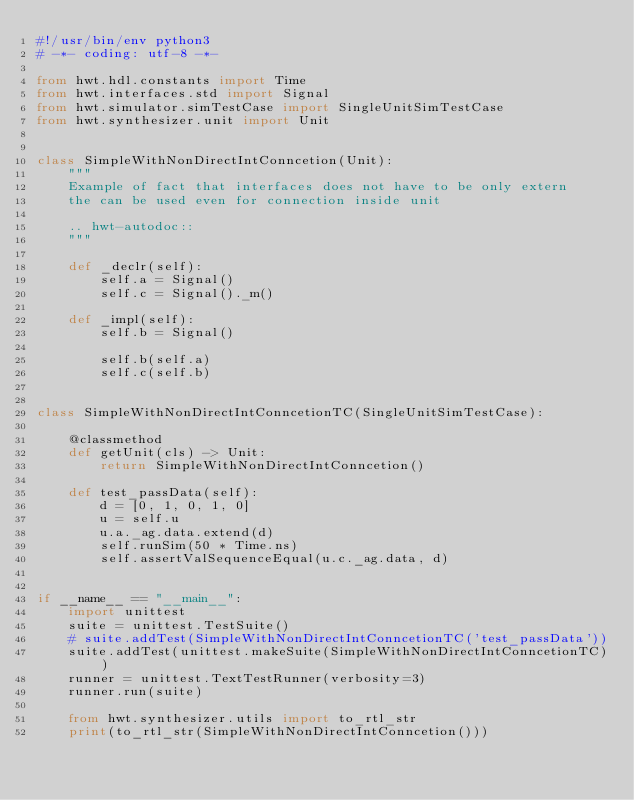Convert code to text. <code><loc_0><loc_0><loc_500><loc_500><_Python_>#!/usr/bin/env python3
# -*- coding: utf-8 -*-

from hwt.hdl.constants import Time
from hwt.interfaces.std import Signal
from hwt.simulator.simTestCase import SingleUnitSimTestCase
from hwt.synthesizer.unit import Unit


class SimpleWithNonDirectIntConncetion(Unit):
    """
    Example of fact that interfaces does not have to be only extern
    the can be used even for connection inside unit

    .. hwt-autodoc::
    """

    def _declr(self):
        self.a = Signal()
        self.c = Signal()._m()

    def _impl(self):
        self.b = Signal()

        self.b(self.a)
        self.c(self.b)


class SimpleWithNonDirectIntConncetionTC(SingleUnitSimTestCase):

    @classmethod
    def getUnit(cls) -> Unit:
        return SimpleWithNonDirectIntConncetion()

    def test_passData(self):
        d = [0, 1, 0, 1, 0]
        u = self.u
        u.a._ag.data.extend(d)
        self.runSim(50 * Time.ns)
        self.assertValSequenceEqual(u.c._ag.data, d)


if __name__ == "__main__":
    import unittest
    suite = unittest.TestSuite()
    # suite.addTest(SimpleWithNonDirectIntConncetionTC('test_passData'))
    suite.addTest(unittest.makeSuite(SimpleWithNonDirectIntConncetionTC))
    runner = unittest.TextTestRunner(verbosity=3)
    runner.run(suite)

    from hwt.synthesizer.utils import to_rtl_str
    print(to_rtl_str(SimpleWithNonDirectIntConncetion()))
</code> 